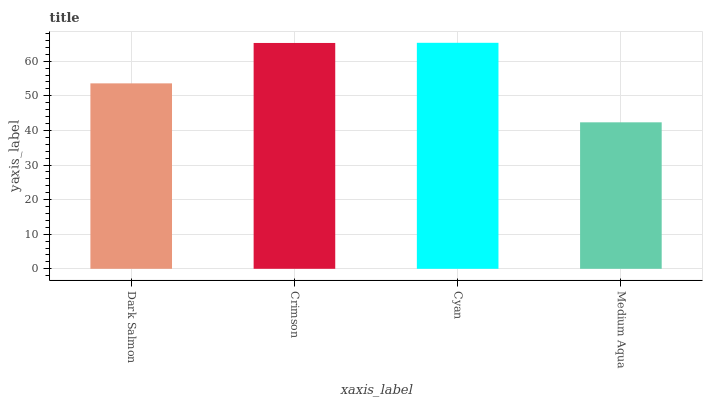Is Crimson the minimum?
Answer yes or no. No. Is Crimson the maximum?
Answer yes or no. No. Is Crimson greater than Dark Salmon?
Answer yes or no. Yes. Is Dark Salmon less than Crimson?
Answer yes or no. Yes. Is Dark Salmon greater than Crimson?
Answer yes or no. No. Is Crimson less than Dark Salmon?
Answer yes or no. No. Is Crimson the high median?
Answer yes or no. Yes. Is Dark Salmon the low median?
Answer yes or no. Yes. Is Dark Salmon the high median?
Answer yes or no. No. Is Crimson the low median?
Answer yes or no. No. 